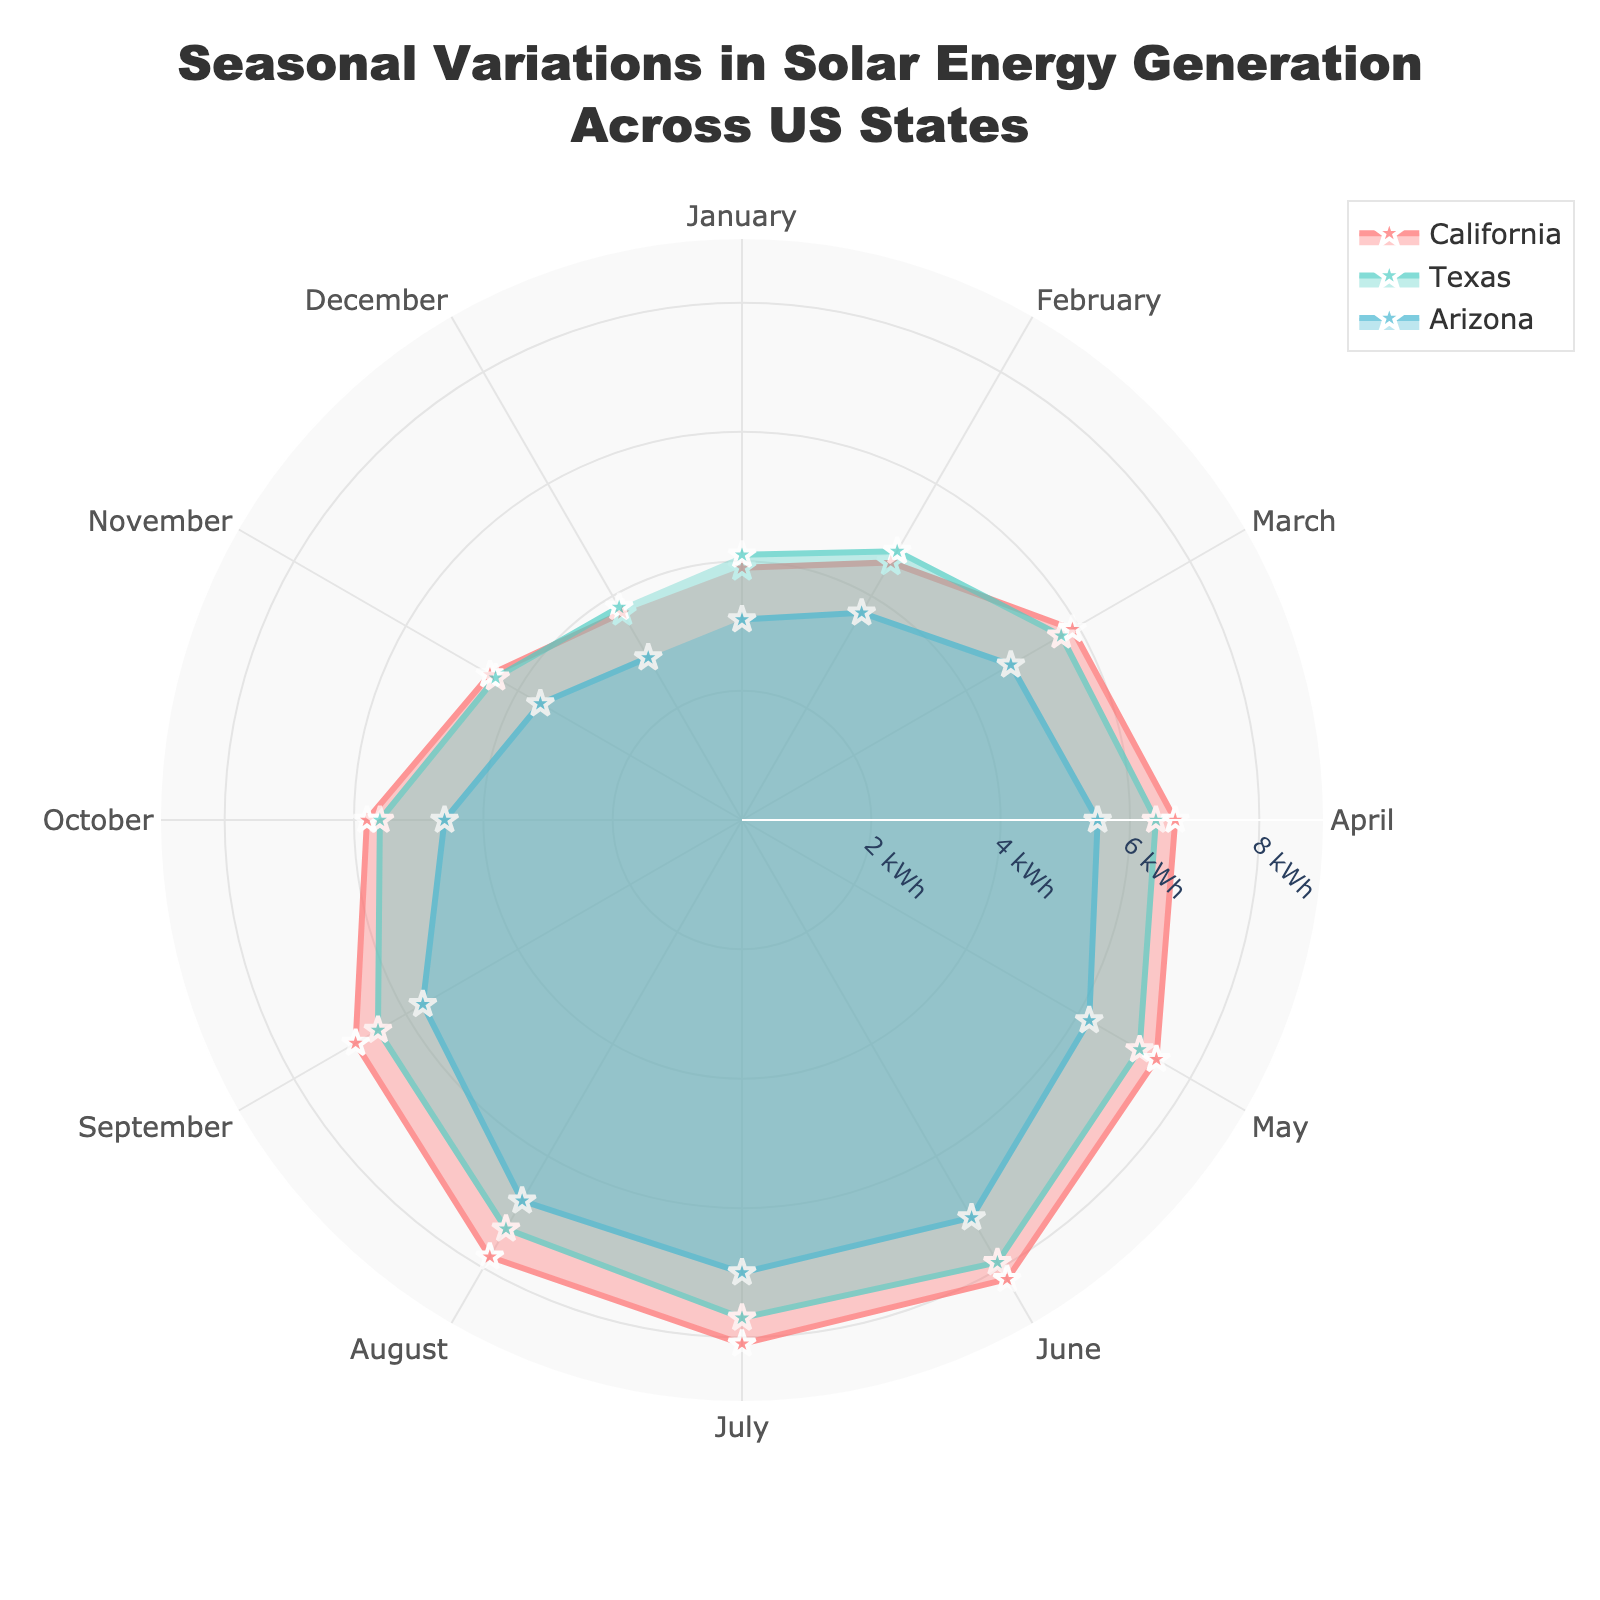Which state generates the most solar energy in July? To determine this, compare the values for July in the figure for each state. California has the highest value at 8.1 kWh.
Answer: California During which month does Texas have its lowest solar energy generation? Check Texas's data points for each month and identify the point with the lowest value. It occurs in December with 3.8 kWh.
Answer: December What is the average solar energy generation for Arizona from March to May? Add the values for Arizona in March (4.8 kWh), April (5.5 kWh), and May (6.2 kWh), then divide by 3. The calculation is (4.8 + 5.5 + 6.2) / 3 = 5.5 kWh.
Answer: 5.5 kWh Which state shows the highest variability in solar energy generation throughout the year? To find the state with the highest variability, identify the range (maximum minus minimum) for each state. California's range is from 3.7 kWh to 8.2 kWh (4.5 kWh), Texas's range is from 3.8 kWh to 7.9 kWh (4.1 kWh), and Arizona's range is from 2.9 kWh to 7.1 kWh (4.2 kWh). Thus, California shows the highest variability.
Answer: California In which month does California reach its peak solar energy generation? Look for the highest value in California's data points. The peak occurs in June with 8.2 kWh.
Answer: June How does the solar energy generation in October compare between California and Arizona? Compare the values for October in California (5.8 kWh) and Arizona (4.6 kWh). California's generation is higher.
Answer: California's generation is higher What is the combined average solar energy generation in April across all three states? Sum the April values for California (6.7 kWh), Texas (6.4 kWh), and Arizona (5.5 kWh), then divide by the number of states. The calculation is (6.7 + 6.4 + 5.5) / 3 = 6.2 kWh.
Answer: 6.2 kWh Which state shows the lowest solar energy generation in January? Compare the January values: California (3.9 kWh), Texas (4.1 kWh), and Arizona (3.1 kWh). Arizona has the lowest value.
Answer: Arizona What is the difference in solar energy generation between May and December for Texas? Subtract the December value (3.8 kWh) from the May value (7.1 kWh). The difference is 7.1 - 3.8 = 3.3 kWh.
Answer: 3.3 kWh How does the pattern of solar energy generation in Texas and California compare over the year? Observe the plots for Texas and California. Both show an increase during the summer months and a decrease during the winter, but the exact values and peak times differ slightly.
Answer: Both have a similar seasonal pattern, with higher values in summer and lower in winter 